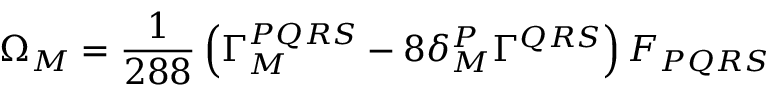Convert formula to latex. <formula><loc_0><loc_0><loc_500><loc_500>\Omega _ { M } = { \frac { 1 } { 2 8 8 } } \left ( \Gamma _ { M } ^ { P Q R S } - 8 \delta _ { M } ^ { P } \Gamma ^ { Q R S } \right ) F _ { P Q R S }</formula> 